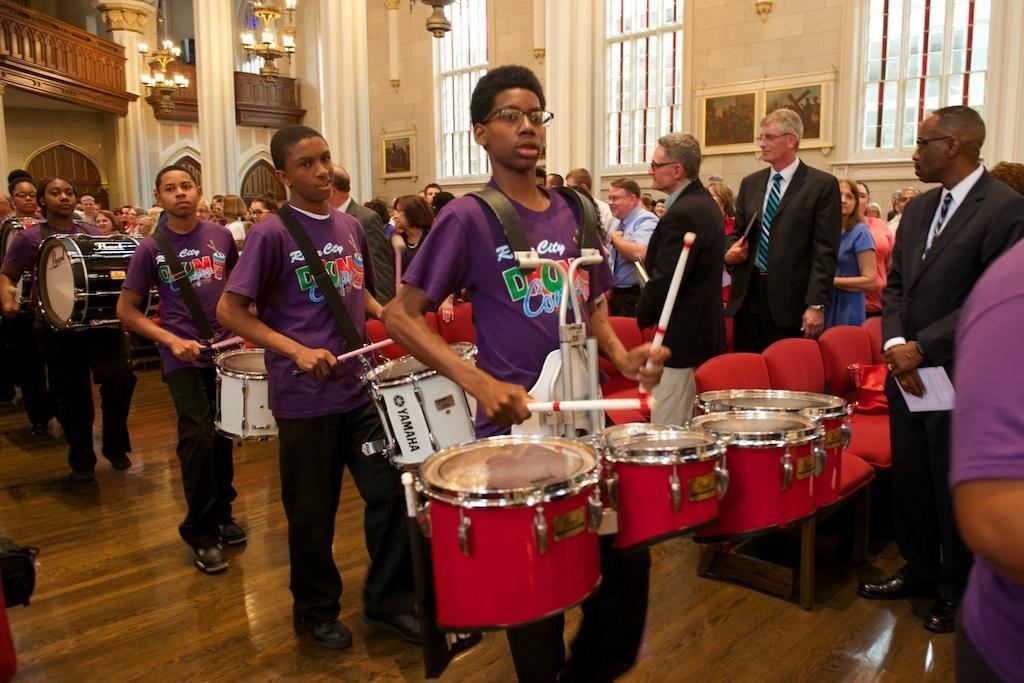How would you summarize this image in a sentence or two? Here we can see some persons are playing drums. These are the chairs and this is floor. Here we can see some persons are standing on the floor. There is a wall and these are the frames. This is pillar and there are lights. 